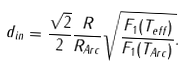<formula> <loc_0><loc_0><loc_500><loc_500>d _ { i n } = \frac { \sqrt { 2 } } { 2 } \frac { R } { R _ { A r c } } \sqrt { \frac { F _ { 1 } ( T _ { e f f } ) } { F _ { 1 } ( T _ { A r c } ) } } .</formula> 